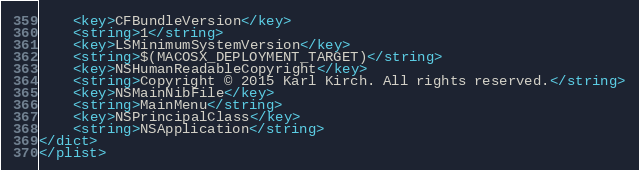Convert code to text. <code><loc_0><loc_0><loc_500><loc_500><_XML_>	<key>CFBundleVersion</key>
	<string>1</string>
	<key>LSMinimumSystemVersion</key>
	<string>$(MACOSX_DEPLOYMENT_TARGET)</string>
	<key>NSHumanReadableCopyright</key>
	<string>Copyright © 2015 Karl Kirch. All rights reserved.</string>
	<key>NSMainNibFile</key>
	<string>MainMenu</string>
	<key>NSPrincipalClass</key>
	<string>NSApplication</string>
</dict>
</plist>
</code> 